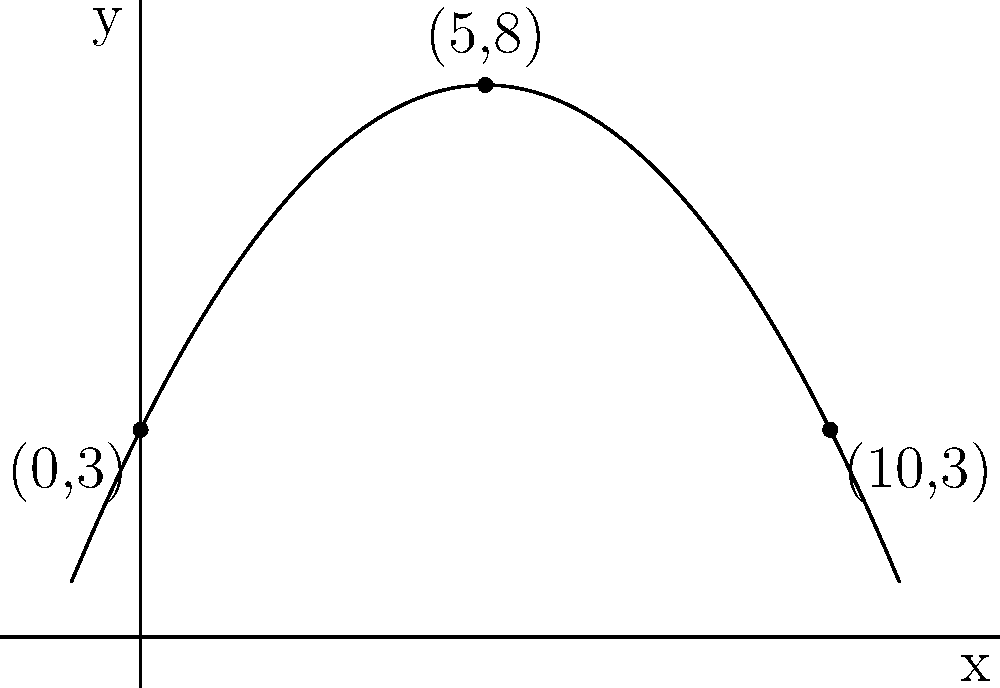As a celebrity chef, you're demonstrating the perfect toss of a spatula. The arc of the spatula forms a parabola, passing through the points (0,3), (5,8), and (10,3) on a coordinate plane where x represents horizontal distance in feet and y represents height in feet. Determine the equation of this parabola in the form $f(x) = ax^2 + bx + c$. Let's approach this step-by-step:

1) The general form of a parabola is $f(x) = ax^2 + bx + c$, where $a$, $b$, and $c$ are constants and $a \neq 0$.

2) We have three points: (0,3), (5,8), and (10,3). Let's substitute these into the general equation:

   (0,3):  $3 = a(0)^2 + b(0) + c$, simplifies to $3 = c$
   (5,8):  $8 = a(5)^2 + b(5) + c$, or $8 = 25a + 5b + 3$
   (10,3): $3 = a(10)^2 + b(10) + c$, or $3 = 100a + 10b + 3$

3) From the first equation, we know that $c = 3$.

4) Subtracting the third equation from the second:
   $5 = -75a - 5b$
   $-1 = 15a + b$

5) From the third equation:
   $0 = 100a + 10b$
   $0 = 10(10a + b)$
   $0 = 10(-1 + 5a)$ (substituting $b = -1 - 15a$ from step 4)
   $0 = -10 + 50a$
   $a = 1/5 = 0.2$

6) Now we can find $b$:
   $-1 = 15(0.2) + b$
   $-1 = 3 + b$
   $b = -4$

7) We now have $a = 0.2$, $b = -4$, and $c = 3$.

8) The equation of the parabola is:
   $f(x) = 0.2x^2 - 4x + 3$

9) To make it match the form in the question, we can write:
   $f(x) = -0.2x^2 + 4x + 3$
Answer: $f(x) = -0.2x^2 + 4x + 3$ 